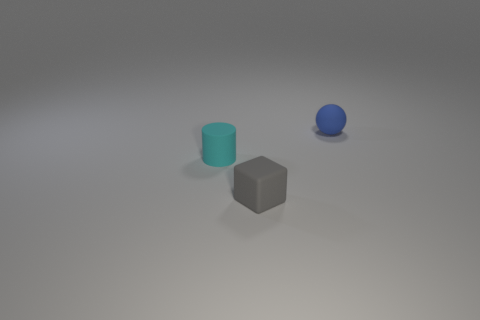Add 3 small cyan matte objects. How many objects exist? 6 Subtract all blocks. How many objects are left? 2 Add 3 small gray rubber cubes. How many small gray rubber cubes are left? 4 Add 2 tiny rubber cylinders. How many tiny rubber cylinders exist? 3 Subtract 0 gray cylinders. How many objects are left? 3 Subtract all large purple balls. Subtract all blocks. How many objects are left? 2 